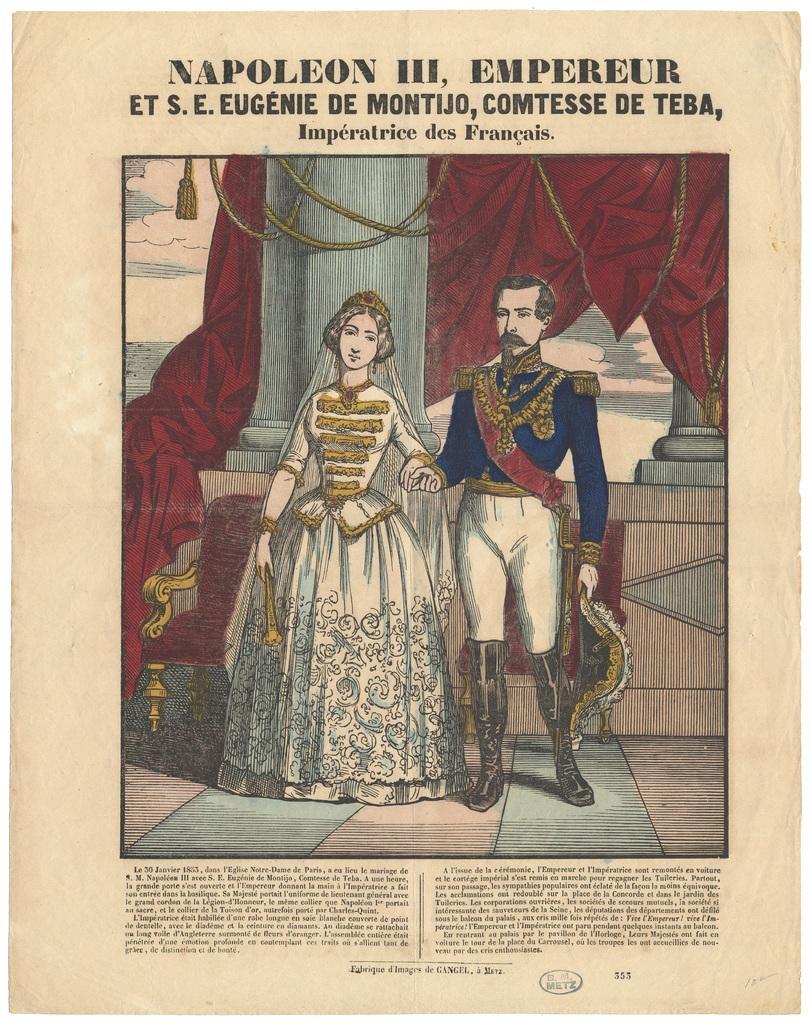In one or two sentences, can you explain what this image depicts? In this image we can see a paper on which a king and queen painting is there and some text was written on the paper. 